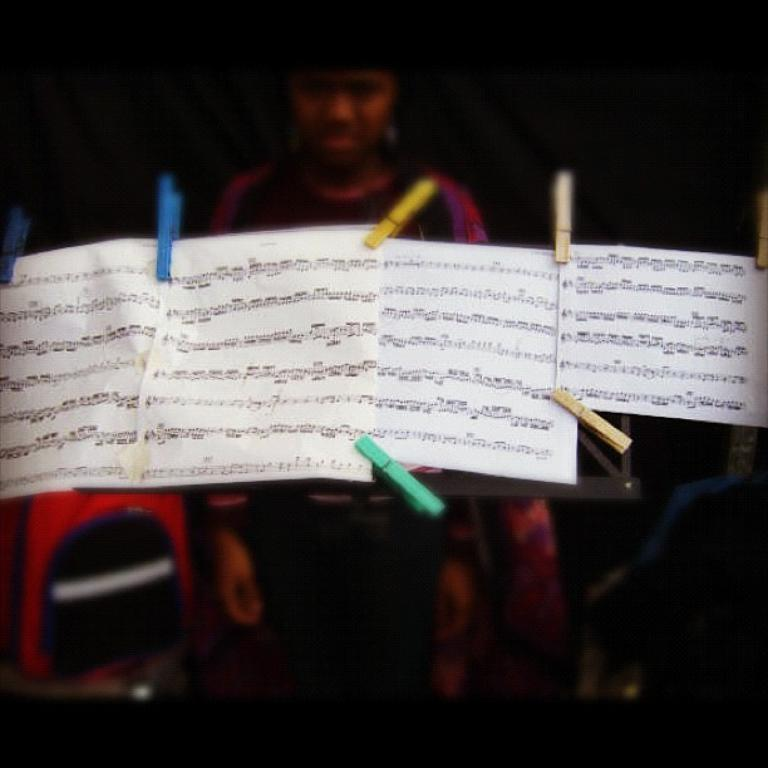What objects are present in the image that are related to paperwork? There are papers with clips in the image. Can you describe the background of the image? The background of the image is blurred. Is there a person visible in the image? Yes, there is a person in the image. What type of care is the person providing to the heart in the image? There is no heart present in the image, and therefore no such care can be observed. 